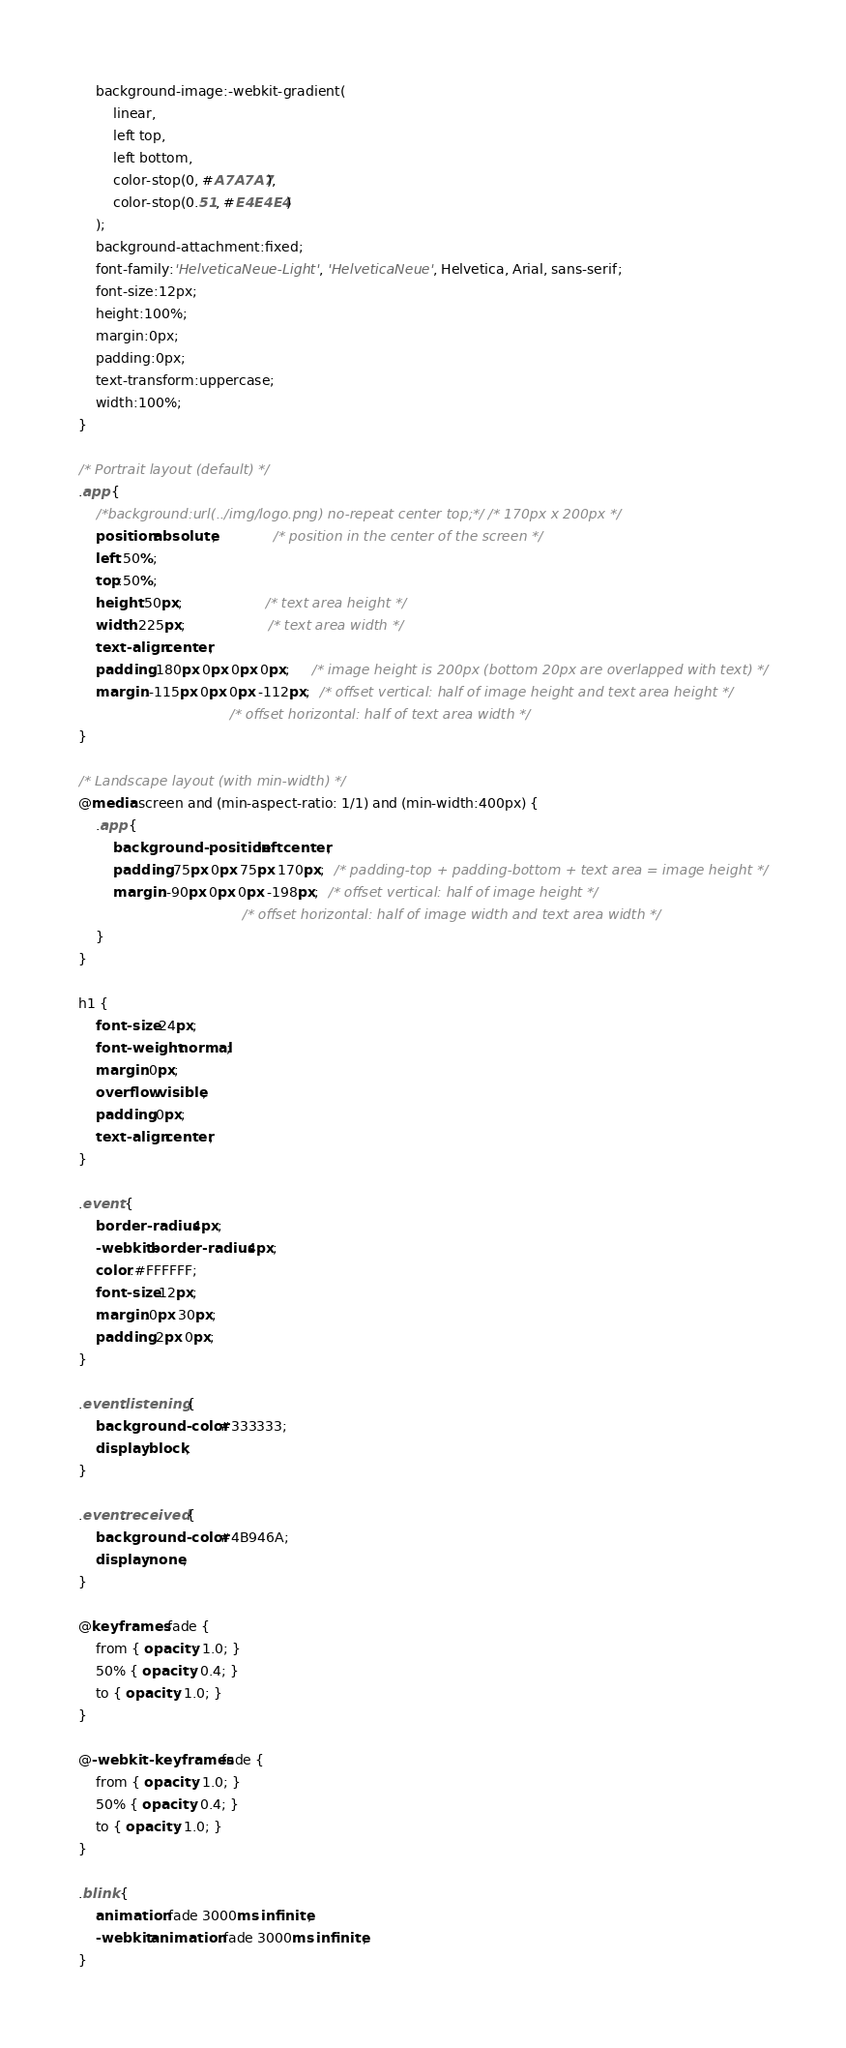<code> <loc_0><loc_0><loc_500><loc_500><_CSS_>    background-image:-webkit-gradient(
        linear,
        left top,
        left bottom,
        color-stop(0, #A7A7A7),
        color-stop(0.51, #E4E4E4)
    );
    background-attachment:fixed;
    font-family:'HelveticaNeue-Light', 'HelveticaNeue', Helvetica, Arial, sans-serif;
    font-size:12px;
    height:100%;
    margin:0px;
    padding:0px;
    text-transform:uppercase;
    width:100%;
}

/* Portrait layout (default) */
.app {
    /*background:url(../img/logo.png) no-repeat center top;*/ /* 170px x 200px */
    position:absolute;             /* position in the center of the screen */
    left:50%;
    top:50%;
    height:50px;                   /* text area height */
    width:225px;                   /* text area width */
    text-align:center;
    padding:180px 0px 0px 0px;     /* image height is 200px (bottom 20px are overlapped with text) */
    margin:-115px 0px 0px -112px;  /* offset vertical: half of image height and text area height */
                                   /* offset horizontal: half of text area width */
}

/* Landscape layout (with min-width) */
@media screen and (min-aspect-ratio: 1/1) and (min-width:400px) {
    .app {
        background-position:left center;
        padding:75px 0px 75px 170px;  /* padding-top + padding-bottom + text area = image height */
        margin:-90px 0px 0px -198px;  /* offset vertical: half of image height */
                                      /* offset horizontal: half of image width and text area width */
    }
}

h1 {
    font-size:24px;
    font-weight:normal;
    margin:0px;
    overflow:visible;
    padding:0px;
    text-align:center;
}

.event {
    border-radius:4px;
    -webkit-border-radius:4px;
    color:#FFFFFF;
    font-size:12px;
    margin:0px 30px;
    padding:2px 0px;
}

.event.listening {
    background-color:#333333;
    display:block;
}

.event.received {
    background-color:#4B946A;
    display:none;
}

@keyframes fade {
    from { opacity: 1.0; }
    50% { opacity: 0.4; }
    to { opacity: 1.0; }
}
 
@-webkit-keyframes fade {
    from { opacity: 1.0; }
    50% { opacity: 0.4; }
    to { opacity: 1.0; }
}
 
.blink {
    animation:fade 3000ms infinite;
    -webkit-animation:fade 3000ms infinite;
}
</code> 